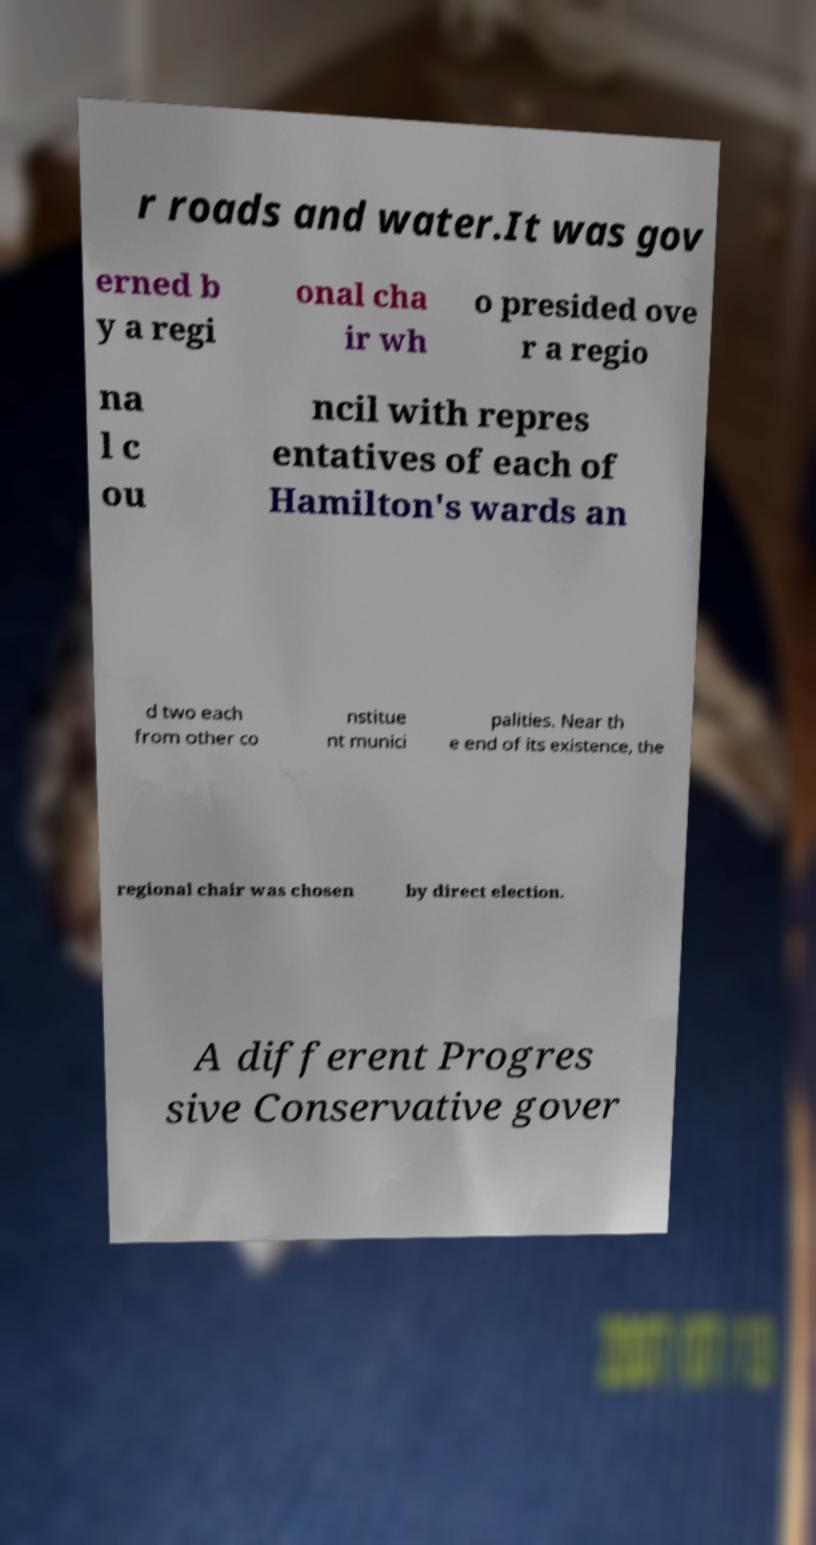Please identify and transcribe the text found in this image. r roads and water.It was gov erned b y a regi onal cha ir wh o presided ove r a regio na l c ou ncil with repres entatives of each of Hamilton's wards an d two each from other co nstitue nt munici palities. Near th e end of its existence, the regional chair was chosen by direct election. A different Progres sive Conservative gover 